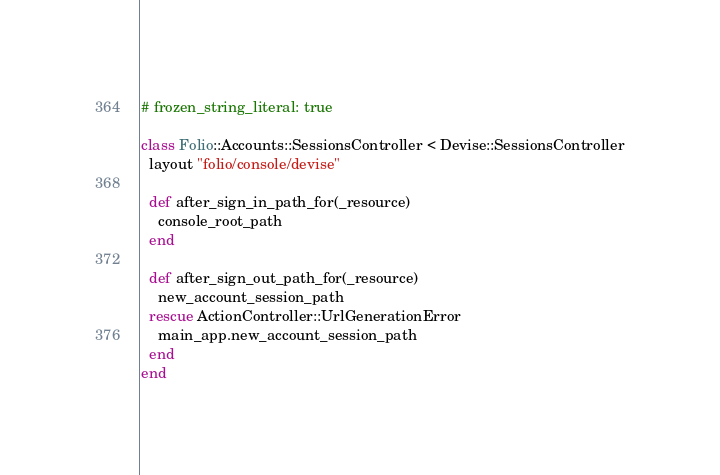<code> <loc_0><loc_0><loc_500><loc_500><_Ruby_># frozen_string_literal: true

class Folio::Accounts::SessionsController < Devise::SessionsController
  layout "folio/console/devise"

  def after_sign_in_path_for(_resource)
    console_root_path
  end

  def after_sign_out_path_for(_resource)
    new_account_session_path
  rescue ActionController::UrlGenerationError
    main_app.new_account_session_path
  end
end
</code> 